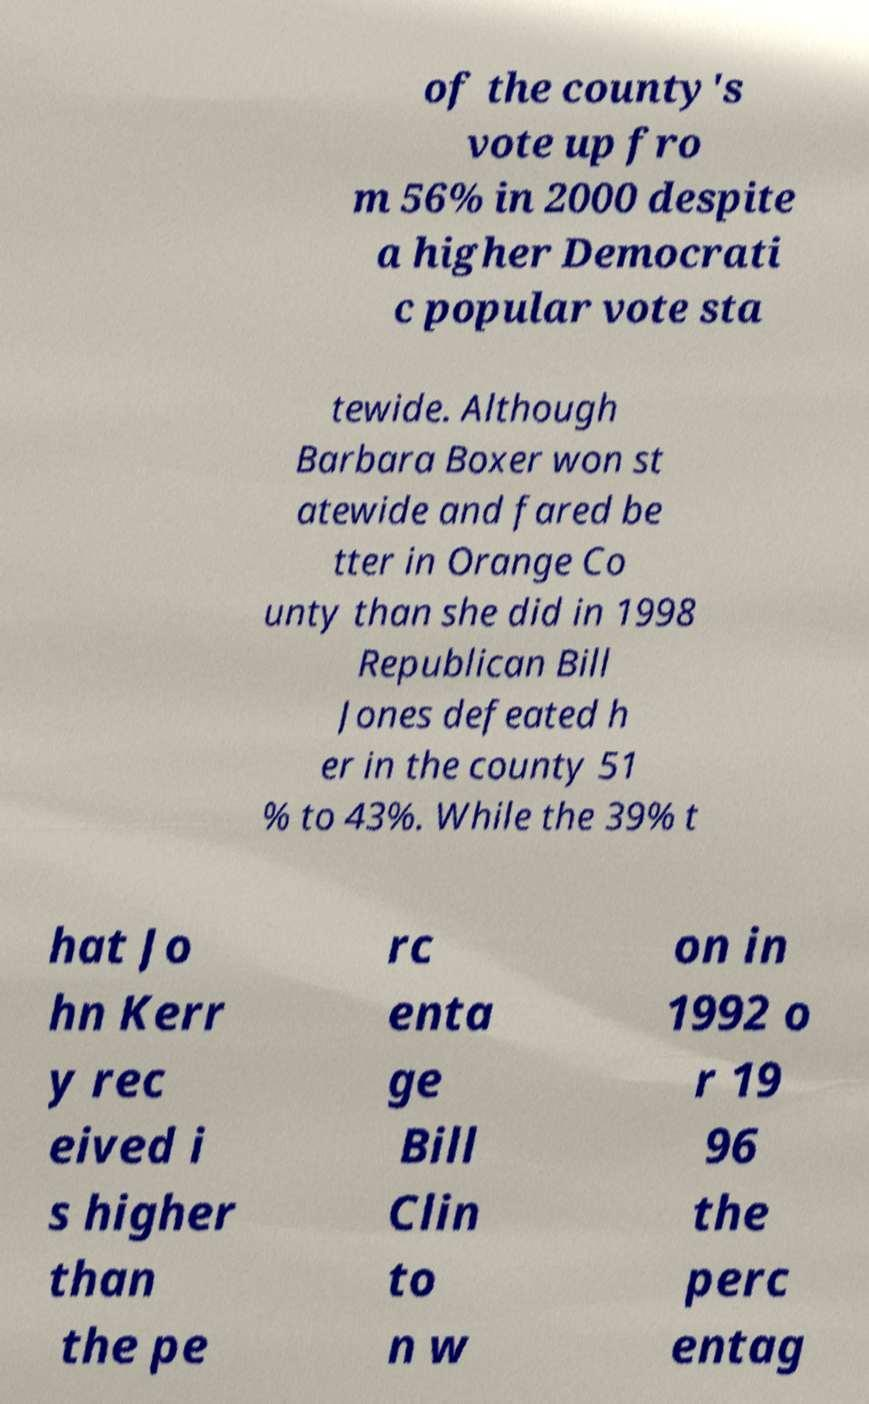Please read and relay the text visible in this image. What does it say? of the county's vote up fro m 56% in 2000 despite a higher Democrati c popular vote sta tewide. Although Barbara Boxer won st atewide and fared be tter in Orange Co unty than she did in 1998 Republican Bill Jones defeated h er in the county 51 % to 43%. While the 39% t hat Jo hn Kerr y rec eived i s higher than the pe rc enta ge Bill Clin to n w on in 1992 o r 19 96 the perc entag 